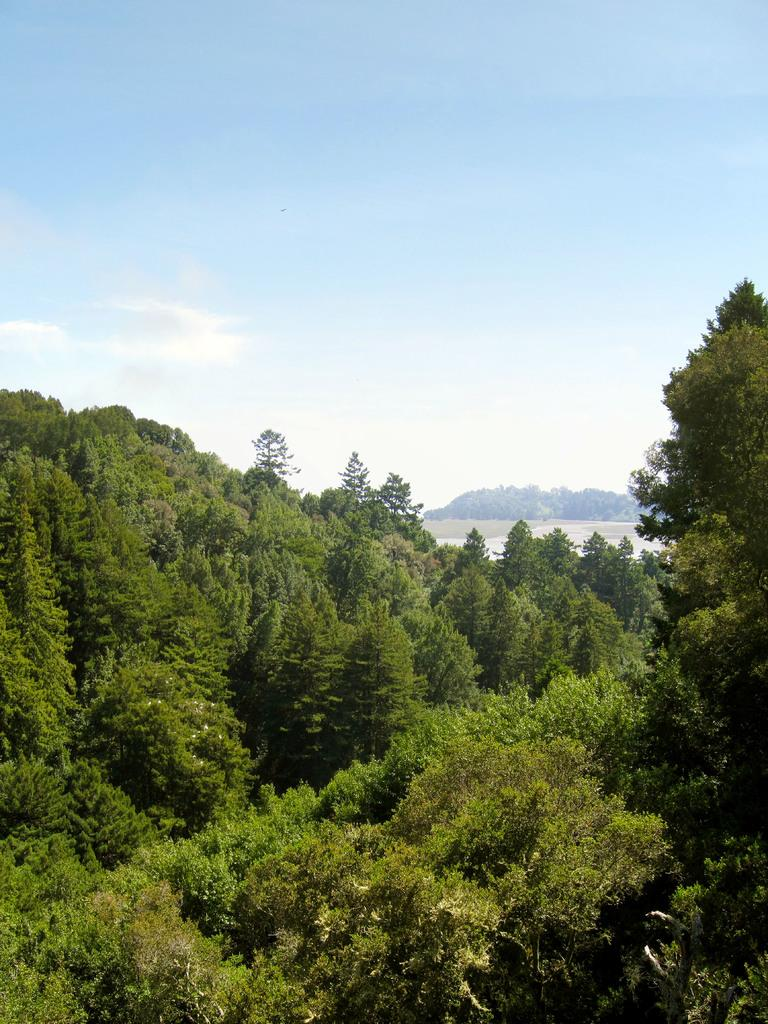What type of vegetation can be seen at the bottom of the image? There are trees at the bottom of the image. Can you describe the trees in the background of the image? There are trees in the background of the image. What is visible at the top of the image? The sky is visible at the top of the image. How many parents are present in the image? There are no parents present in the image, as it only features trees and the sky. What type of cast can be seen in the image? There is no cast present in the image; it only features trees and the sky. 